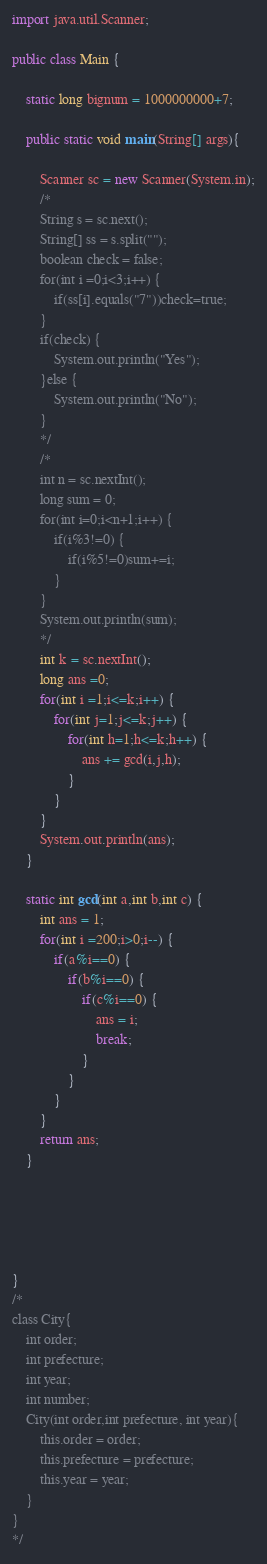<code> <loc_0><loc_0><loc_500><loc_500><_Java_>import java.util.Scanner;

public class Main {

	static long bignum = 1000000000+7;

	public static void main(String[] args){

		Scanner sc = new Scanner(System.in);
		/*
		String s = sc.next();
		String[] ss = s.split("");
		boolean check = false;
		for(int i =0;i<3;i++) {
			if(ss[i].equals("7"))check=true;
		}
		if(check) {
			System.out.println("Yes");
		}else {
			System.out.println("No");
		}
		*/
		/*
		int n = sc.nextInt();
		long sum = 0;
		for(int i=0;i<n+1;i++) {
			if(i%3!=0) {
				if(i%5!=0)sum+=i;
			}
		}
		System.out.println(sum);
		*/
		int k = sc.nextInt();
		long ans =0;
		for(int i =1;i<=k;i++) {
			for(int j=1;j<=k;j++) {
				for(int h=1;h<=k;h++) {
					ans += gcd(i,j,h);
				}
			}
		}
		System.out.println(ans);
	}

	static int gcd(int a,int b,int c) {
		int ans = 1;
		for(int i =200;i>0;i--) {
			if(a%i==0) {
				if(b%i==0) {
					if(c%i==0) {
						ans = i;
						break;
					}
				}
			}
		}
		return ans;
	}





}
/*
class City{
	int order;
	int prefecture;
	int year;
	int number;
	City(int order,int prefecture, int year){
		this.order = order;
		this.prefecture = prefecture;
		this.year = year;
	}
}
*/
</code> 